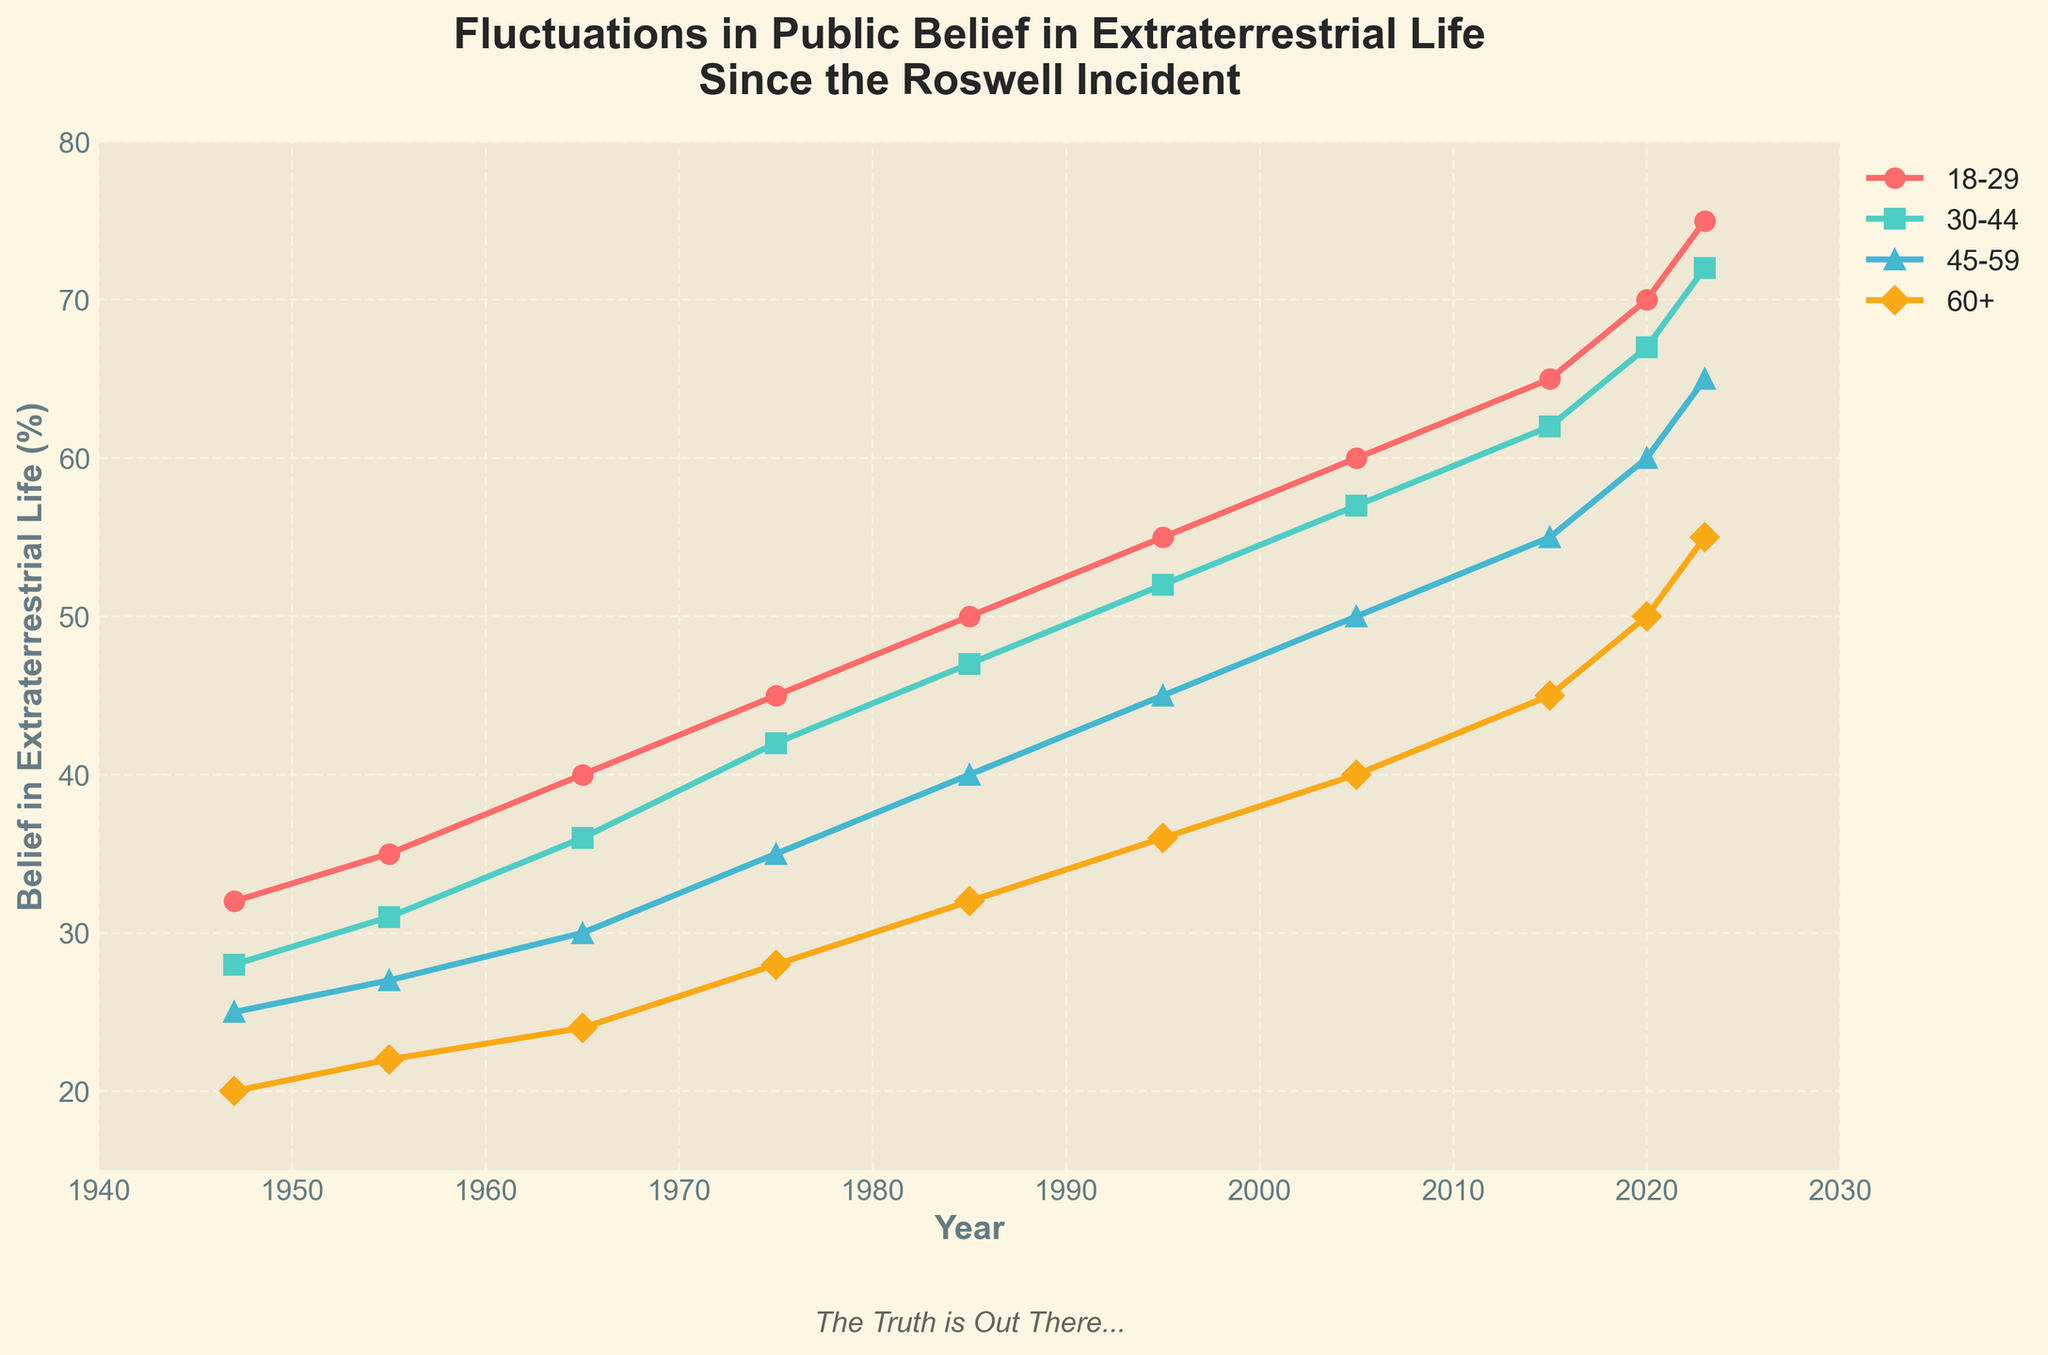What age group shows the largest increase in belief from 1947 to 2023? Look at the starting and ending percentages for each age group. Calculate the difference for each: 18-29: 75-32=43, 30-44: 72-28=44, 45-59: 65-25=40, 60+: 55-20=35. The largest increase is for the 30-44 group.
Answer: 30-44 Which age group had the smallest percentage believing in extraterrestrial life in 1947? Check the values for each age group in 1947: 18-29: 32, 30-44: 28, 45-59: 25, 60+: 20. The smallest is for the 60+ group.
Answer: 60+ Compare the belief levels in 2023 for the 18-29 and 60+ age groups. Which is higher and by how much? Find the values for each age group in 2023: 18-29: 75, 60+: 55. Subtract the smaller from the larger: 75-55=20. The 18-29 group is higher by 20.
Answer: 18-29 by 20 What is the average belief percentage for the 45-59 age group over the given years? Add the percentages for the 45-59 group: 25+27+30+35+40+45+50+55+60+65. Their sum is 432. Since there are 10 data points, average: 432/10=43.2
Answer: 43.2 In which decade did the 30-44 age group surpass the 45-59 age group in belief percentage? Compare the values: In 1947, 30-44 has 28, and 45-59 has 25. In 1955, 30-44 has 31, and 45-59 has 27. By 1965, 30-44 has 36, and 45-59 has 30, showing the 30-44 group surpassed 45-59 in the 1950s.
Answer: 1950s What is the difference in belief percentage between the 30-44 and 60+ age groups in 2020? Look at the values for each group in 2020: 30-44: 67, 60+: 50. Subtract the smaller from the larger: 67-50=17.
Answer: 17 How much did the belief percentage for the 18-29 group increase between 1985 and 2023? Check the values for 18-29 in 1985 (50) and 2023 (75). Subtract 50 from 75 to find the increase: 75-50=25.
Answer: 25 In which years did the belief percentage for the 60+ group reach each decade's highest points? Check the values for each decade and find the highest: 1947-1957: 1955 (22), 1958-1967: 1965 (24), 1968-1977: 1975 (28), 1978-1987: 1985 (32), 1988-1997: 1995 (36), 1998-2007: 2005 (40), 2008-2017: 2015 (45), 2018-2023: 2023 (55).
Answer: 1955, 1965, 1975, 1985, 1995, 2005, 2015, 2023 